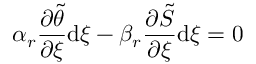<formula> <loc_0><loc_0><loc_500><loc_500>\alpha _ { r } \frac { \partial \tilde { \theta } } { \partial \xi } d \xi - \beta _ { r } \frac { \partial \tilde { S } } { \partial \xi } d \xi = 0</formula> 